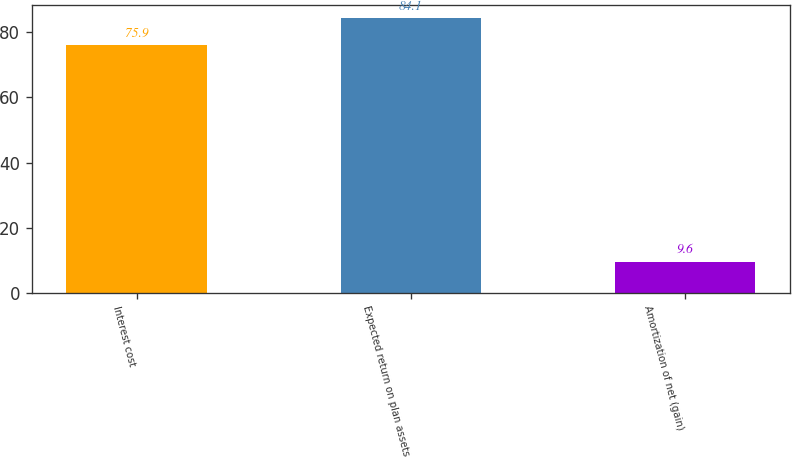Convert chart. <chart><loc_0><loc_0><loc_500><loc_500><bar_chart><fcel>Interest cost<fcel>Expected return on plan assets<fcel>Amortization of net (gain)<nl><fcel>75.9<fcel>84.1<fcel>9.6<nl></chart> 